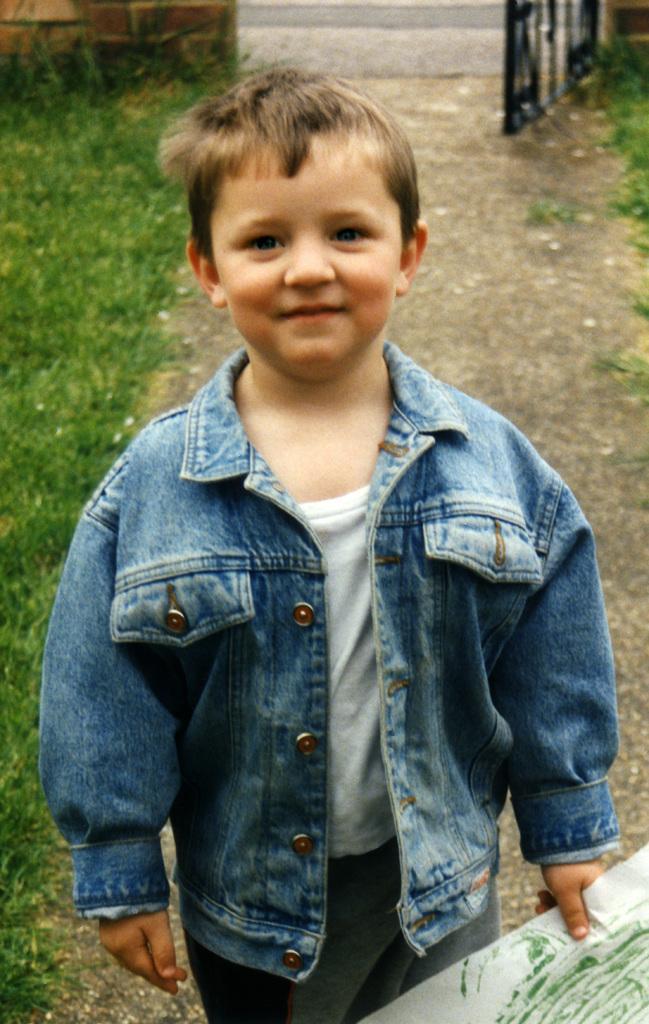How would you summarize this image in a sentence or two? In this image we can see the boy wearing a jacket is holding a paper in his hand. In the background, we can see a gate. 